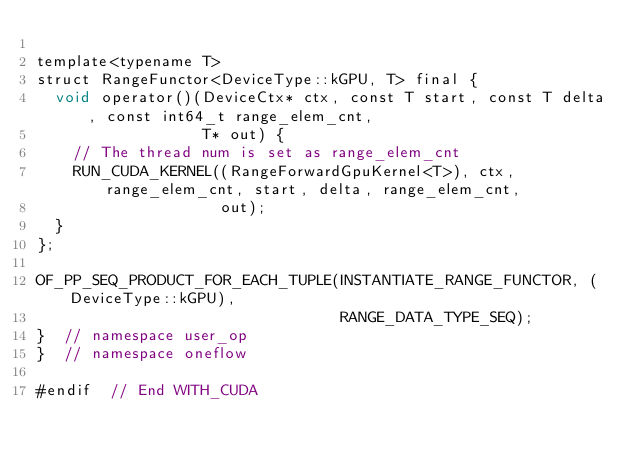<code> <loc_0><loc_0><loc_500><loc_500><_Cuda_>
template<typename T>
struct RangeFunctor<DeviceType::kGPU, T> final {
  void operator()(DeviceCtx* ctx, const T start, const T delta, const int64_t range_elem_cnt,
                  T* out) {
    // The thread num is set as range_elem_cnt
    RUN_CUDA_KERNEL((RangeForwardGpuKernel<T>), ctx, range_elem_cnt, start, delta, range_elem_cnt,
                    out);
  }
};

OF_PP_SEQ_PRODUCT_FOR_EACH_TUPLE(INSTANTIATE_RANGE_FUNCTOR, (DeviceType::kGPU),
                                 RANGE_DATA_TYPE_SEQ);
}  // namespace user_op
}  // namespace oneflow

#endif  // End WITH_CUDA
</code> 